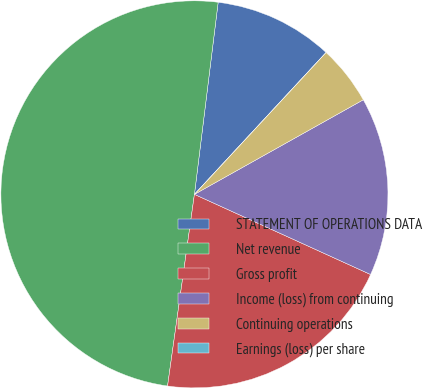Convert chart to OTSL. <chart><loc_0><loc_0><loc_500><loc_500><pie_chart><fcel>STATEMENT OF OPERATIONS DATA<fcel>Net revenue<fcel>Gross profit<fcel>Income (loss) from continuing<fcel>Continuing operations<fcel>Earnings (loss) per share<nl><fcel>9.95%<fcel>49.74%<fcel>20.42%<fcel>14.92%<fcel>4.97%<fcel>0.0%<nl></chart> 